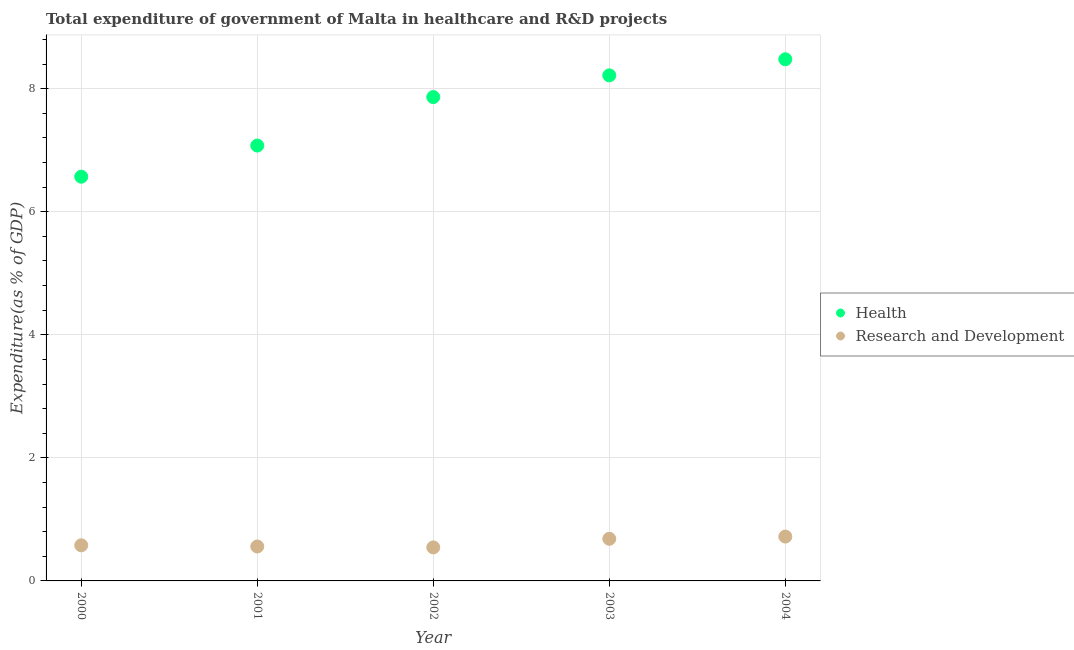How many different coloured dotlines are there?
Make the answer very short. 2. What is the expenditure in r&d in 2004?
Make the answer very short. 0.72. Across all years, what is the maximum expenditure in healthcare?
Offer a terse response. 8.48. Across all years, what is the minimum expenditure in r&d?
Make the answer very short. 0.54. In which year was the expenditure in healthcare minimum?
Provide a short and direct response. 2000. What is the total expenditure in healthcare in the graph?
Your answer should be compact. 38.2. What is the difference between the expenditure in r&d in 2003 and that in 2004?
Your answer should be very brief. -0.04. What is the difference between the expenditure in healthcare in 2000 and the expenditure in r&d in 2004?
Your answer should be compact. 5.85. What is the average expenditure in healthcare per year?
Give a very brief answer. 7.64. In the year 2004, what is the difference between the expenditure in r&d and expenditure in healthcare?
Your response must be concise. -7.76. What is the ratio of the expenditure in r&d in 2000 to that in 2004?
Make the answer very short. 0.8. Is the expenditure in r&d in 2000 less than that in 2004?
Provide a short and direct response. Yes. Is the difference between the expenditure in r&d in 2002 and 2003 greater than the difference between the expenditure in healthcare in 2002 and 2003?
Make the answer very short. Yes. What is the difference between the highest and the second highest expenditure in r&d?
Provide a succinct answer. 0.04. What is the difference between the highest and the lowest expenditure in healthcare?
Offer a terse response. 1.91. In how many years, is the expenditure in healthcare greater than the average expenditure in healthcare taken over all years?
Make the answer very short. 3. Is the sum of the expenditure in healthcare in 2001 and 2004 greater than the maximum expenditure in r&d across all years?
Keep it short and to the point. Yes. Is the expenditure in r&d strictly less than the expenditure in healthcare over the years?
Provide a succinct answer. Yes. How many dotlines are there?
Provide a short and direct response. 2. How many years are there in the graph?
Your response must be concise. 5. What is the difference between two consecutive major ticks on the Y-axis?
Your response must be concise. 2. Are the values on the major ticks of Y-axis written in scientific E-notation?
Your answer should be very brief. No. Does the graph contain any zero values?
Give a very brief answer. No. Does the graph contain grids?
Keep it short and to the point. Yes. Where does the legend appear in the graph?
Your response must be concise. Center right. How many legend labels are there?
Provide a succinct answer. 2. What is the title of the graph?
Provide a short and direct response. Total expenditure of government of Malta in healthcare and R&D projects. What is the label or title of the Y-axis?
Provide a succinct answer. Expenditure(as % of GDP). What is the Expenditure(as % of GDP) of Health in 2000?
Keep it short and to the point. 6.57. What is the Expenditure(as % of GDP) of Research and Development in 2000?
Provide a short and direct response. 0.58. What is the Expenditure(as % of GDP) of Health in 2001?
Provide a short and direct response. 7.08. What is the Expenditure(as % of GDP) of Research and Development in 2001?
Ensure brevity in your answer.  0.56. What is the Expenditure(as % of GDP) of Health in 2002?
Ensure brevity in your answer.  7.86. What is the Expenditure(as % of GDP) in Research and Development in 2002?
Your answer should be compact. 0.54. What is the Expenditure(as % of GDP) of Health in 2003?
Offer a very short reply. 8.22. What is the Expenditure(as % of GDP) of Research and Development in 2003?
Give a very brief answer. 0.68. What is the Expenditure(as % of GDP) in Health in 2004?
Offer a very short reply. 8.48. What is the Expenditure(as % of GDP) of Research and Development in 2004?
Provide a short and direct response. 0.72. Across all years, what is the maximum Expenditure(as % of GDP) of Health?
Your answer should be very brief. 8.48. Across all years, what is the maximum Expenditure(as % of GDP) of Research and Development?
Make the answer very short. 0.72. Across all years, what is the minimum Expenditure(as % of GDP) of Health?
Provide a short and direct response. 6.57. Across all years, what is the minimum Expenditure(as % of GDP) of Research and Development?
Your answer should be very brief. 0.54. What is the total Expenditure(as % of GDP) in Health in the graph?
Offer a very short reply. 38.2. What is the total Expenditure(as % of GDP) of Research and Development in the graph?
Give a very brief answer. 3.09. What is the difference between the Expenditure(as % of GDP) of Health in 2000 and that in 2001?
Your answer should be very brief. -0.51. What is the difference between the Expenditure(as % of GDP) of Research and Development in 2000 and that in 2001?
Keep it short and to the point. 0.02. What is the difference between the Expenditure(as % of GDP) of Health in 2000 and that in 2002?
Provide a succinct answer. -1.29. What is the difference between the Expenditure(as % of GDP) of Research and Development in 2000 and that in 2002?
Your answer should be compact. 0.03. What is the difference between the Expenditure(as % of GDP) in Health in 2000 and that in 2003?
Make the answer very short. -1.65. What is the difference between the Expenditure(as % of GDP) in Research and Development in 2000 and that in 2003?
Provide a short and direct response. -0.11. What is the difference between the Expenditure(as % of GDP) of Health in 2000 and that in 2004?
Ensure brevity in your answer.  -1.91. What is the difference between the Expenditure(as % of GDP) of Research and Development in 2000 and that in 2004?
Your answer should be very brief. -0.14. What is the difference between the Expenditure(as % of GDP) in Health in 2001 and that in 2002?
Your response must be concise. -0.79. What is the difference between the Expenditure(as % of GDP) of Research and Development in 2001 and that in 2002?
Provide a succinct answer. 0.01. What is the difference between the Expenditure(as % of GDP) of Health in 2001 and that in 2003?
Give a very brief answer. -1.14. What is the difference between the Expenditure(as % of GDP) in Research and Development in 2001 and that in 2003?
Provide a succinct answer. -0.13. What is the difference between the Expenditure(as % of GDP) in Health in 2001 and that in 2004?
Provide a succinct answer. -1.4. What is the difference between the Expenditure(as % of GDP) of Research and Development in 2001 and that in 2004?
Keep it short and to the point. -0.16. What is the difference between the Expenditure(as % of GDP) of Health in 2002 and that in 2003?
Offer a terse response. -0.35. What is the difference between the Expenditure(as % of GDP) in Research and Development in 2002 and that in 2003?
Keep it short and to the point. -0.14. What is the difference between the Expenditure(as % of GDP) of Health in 2002 and that in 2004?
Provide a succinct answer. -0.61. What is the difference between the Expenditure(as % of GDP) in Research and Development in 2002 and that in 2004?
Your answer should be very brief. -0.18. What is the difference between the Expenditure(as % of GDP) in Health in 2003 and that in 2004?
Offer a very short reply. -0.26. What is the difference between the Expenditure(as % of GDP) of Research and Development in 2003 and that in 2004?
Provide a short and direct response. -0.04. What is the difference between the Expenditure(as % of GDP) in Health in 2000 and the Expenditure(as % of GDP) in Research and Development in 2001?
Your answer should be very brief. 6.01. What is the difference between the Expenditure(as % of GDP) of Health in 2000 and the Expenditure(as % of GDP) of Research and Development in 2002?
Offer a very short reply. 6.03. What is the difference between the Expenditure(as % of GDP) of Health in 2000 and the Expenditure(as % of GDP) of Research and Development in 2003?
Your response must be concise. 5.88. What is the difference between the Expenditure(as % of GDP) in Health in 2000 and the Expenditure(as % of GDP) in Research and Development in 2004?
Provide a short and direct response. 5.85. What is the difference between the Expenditure(as % of GDP) in Health in 2001 and the Expenditure(as % of GDP) in Research and Development in 2002?
Provide a short and direct response. 6.53. What is the difference between the Expenditure(as % of GDP) of Health in 2001 and the Expenditure(as % of GDP) of Research and Development in 2003?
Keep it short and to the point. 6.39. What is the difference between the Expenditure(as % of GDP) in Health in 2001 and the Expenditure(as % of GDP) in Research and Development in 2004?
Your response must be concise. 6.36. What is the difference between the Expenditure(as % of GDP) of Health in 2002 and the Expenditure(as % of GDP) of Research and Development in 2003?
Provide a short and direct response. 7.18. What is the difference between the Expenditure(as % of GDP) in Health in 2002 and the Expenditure(as % of GDP) in Research and Development in 2004?
Offer a terse response. 7.14. What is the difference between the Expenditure(as % of GDP) of Health in 2003 and the Expenditure(as % of GDP) of Research and Development in 2004?
Provide a short and direct response. 7.5. What is the average Expenditure(as % of GDP) of Health per year?
Your answer should be very brief. 7.64. What is the average Expenditure(as % of GDP) in Research and Development per year?
Give a very brief answer. 0.62. In the year 2000, what is the difference between the Expenditure(as % of GDP) in Health and Expenditure(as % of GDP) in Research and Development?
Provide a short and direct response. 5.99. In the year 2001, what is the difference between the Expenditure(as % of GDP) of Health and Expenditure(as % of GDP) of Research and Development?
Provide a succinct answer. 6.52. In the year 2002, what is the difference between the Expenditure(as % of GDP) of Health and Expenditure(as % of GDP) of Research and Development?
Give a very brief answer. 7.32. In the year 2003, what is the difference between the Expenditure(as % of GDP) in Health and Expenditure(as % of GDP) in Research and Development?
Offer a terse response. 7.53. In the year 2004, what is the difference between the Expenditure(as % of GDP) in Health and Expenditure(as % of GDP) in Research and Development?
Give a very brief answer. 7.76. What is the ratio of the Expenditure(as % of GDP) of Health in 2000 to that in 2001?
Provide a succinct answer. 0.93. What is the ratio of the Expenditure(as % of GDP) in Research and Development in 2000 to that in 2001?
Your answer should be compact. 1.03. What is the ratio of the Expenditure(as % of GDP) of Health in 2000 to that in 2002?
Give a very brief answer. 0.84. What is the ratio of the Expenditure(as % of GDP) of Research and Development in 2000 to that in 2002?
Your answer should be compact. 1.06. What is the ratio of the Expenditure(as % of GDP) in Health in 2000 to that in 2003?
Provide a short and direct response. 0.8. What is the ratio of the Expenditure(as % of GDP) of Research and Development in 2000 to that in 2003?
Ensure brevity in your answer.  0.85. What is the ratio of the Expenditure(as % of GDP) of Health in 2000 to that in 2004?
Your response must be concise. 0.77. What is the ratio of the Expenditure(as % of GDP) of Research and Development in 2000 to that in 2004?
Your answer should be very brief. 0.8. What is the ratio of the Expenditure(as % of GDP) of Health in 2001 to that in 2002?
Offer a terse response. 0.9. What is the ratio of the Expenditure(as % of GDP) in Research and Development in 2001 to that in 2002?
Your response must be concise. 1.03. What is the ratio of the Expenditure(as % of GDP) of Health in 2001 to that in 2003?
Ensure brevity in your answer.  0.86. What is the ratio of the Expenditure(as % of GDP) in Research and Development in 2001 to that in 2003?
Your answer should be compact. 0.82. What is the ratio of the Expenditure(as % of GDP) of Health in 2001 to that in 2004?
Ensure brevity in your answer.  0.83. What is the ratio of the Expenditure(as % of GDP) of Research and Development in 2001 to that in 2004?
Provide a succinct answer. 0.78. What is the ratio of the Expenditure(as % of GDP) of Health in 2002 to that in 2003?
Your answer should be very brief. 0.96. What is the ratio of the Expenditure(as % of GDP) in Research and Development in 2002 to that in 2003?
Provide a short and direct response. 0.8. What is the ratio of the Expenditure(as % of GDP) in Health in 2002 to that in 2004?
Offer a very short reply. 0.93. What is the ratio of the Expenditure(as % of GDP) of Research and Development in 2002 to that in 2004?
Your response must be concise. 0.76. What is the ratio of the Expenditure(as % of GDP) in Health in 2003 to that in 2004?
Provide a succinct answer. 0.97. What is the ratio of the Expenditure(as % of GDP) of Research and Development in 2003 to that in 2004?
Provide a short and direct response. 0.95. What is the difference between the highest and the second highest Expenditure(as % of GDP) of Health?
Your answer should be very brief. 0.26. What is the difference between the highest and the second highest Expenditure(as % of GDP) in Research and Development?
Offer a terse response. 0.04. What is the difference between the highest and the lowest Expenditure(as % of GDP) of Health?
Make the answer very short. 1.91. What is the difference between the highest and the lowest Expenditure(as % of GDP) of Research and Development?
Offer a very short reply. 0.18. 